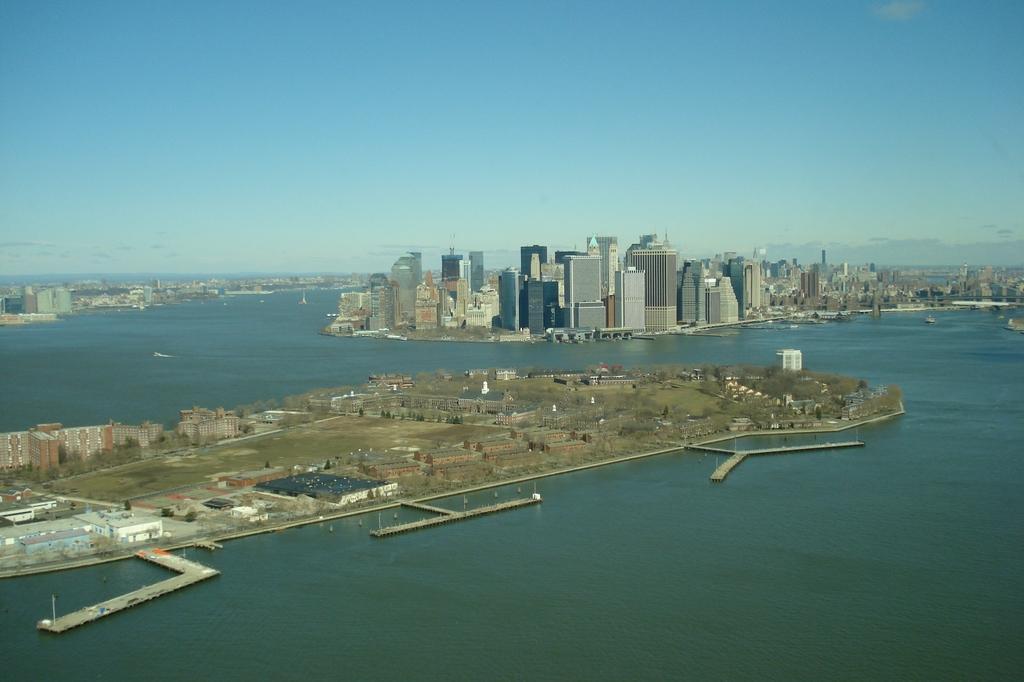Could you give a brief overview of what you see in this image? In this image we can see water, ground, trees, bridges, and buildings. In the background there is sky with clouds. 